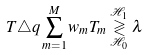<formula> <loc_0><loc_0><loc_500><loc_500>T \triangle q \sum _ { m = 1 } ^ { M } w _ { m } T _ { m } \overset { \mathcal { H } _ { 1 } } { \underset { \mathcal { H } _ { 0 } } { \gtrless } } \lambda</formula> 